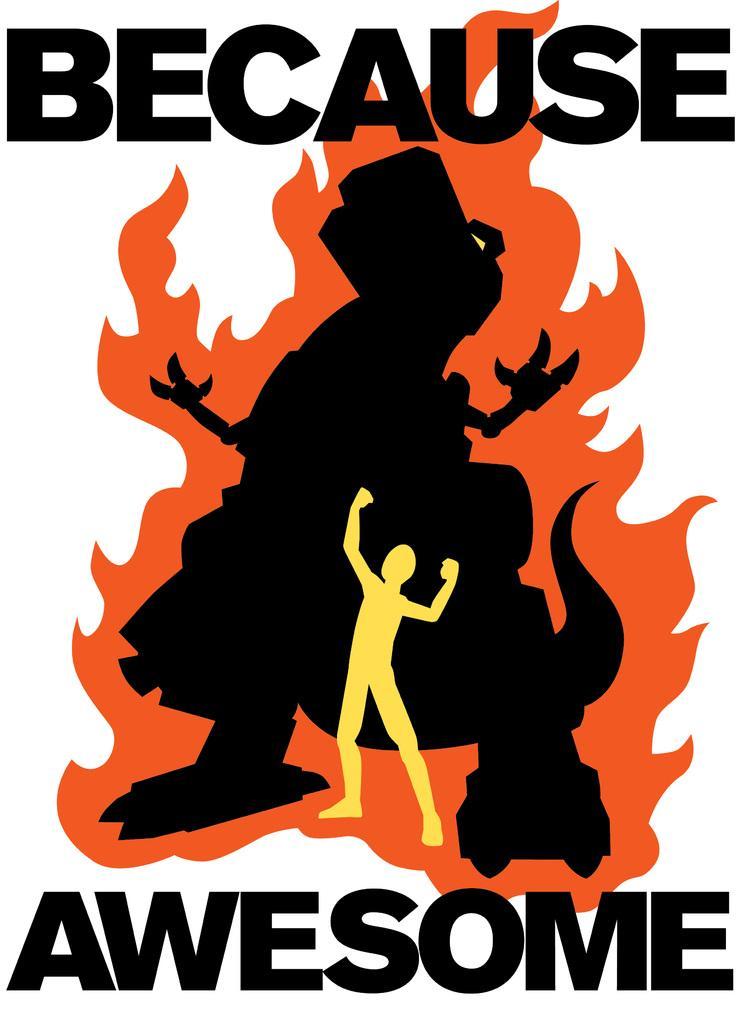How would you summarize this image in a sentence or two? This image contains a picture of an animal and a person. Middle of the image there is an animal. Before it there is a person standing. Bottom of the image there is some text. Background is in white color. 